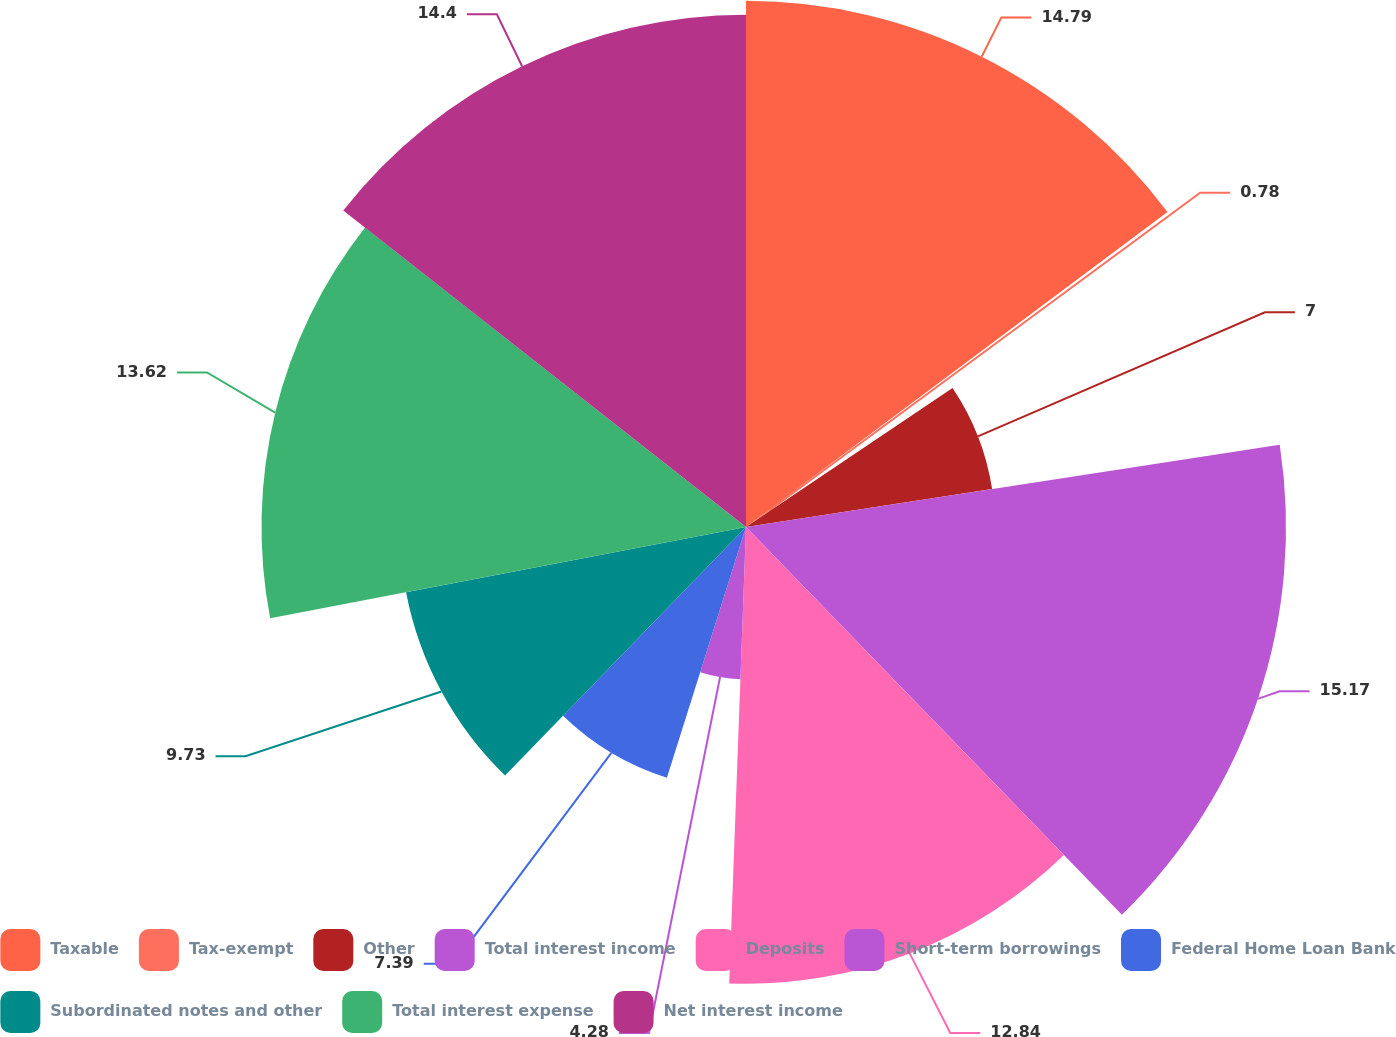<chart> <loc_0><loc_0><loc_500><loc_500><pie_chart><fcel>Taxable<fcel>Tax-exempt<fcel>Other<fcel>Total interest income<fcel>Deposits<fcel>Short-term borrowings<fcel>Federal Home Loan Bank<fcel>Subordinated notes and other<fcel>Total interest expense<fcel>Net interest income<nl><fcel>14.79%<fcel>0.78%<fcel>7.0%<fcel>15.18%<fcel>12.84%<fcel>4.28%<fcel>7.39%<fcel>9.73%<fcel>13.62%<fcel>14.4%<nl></chart> 